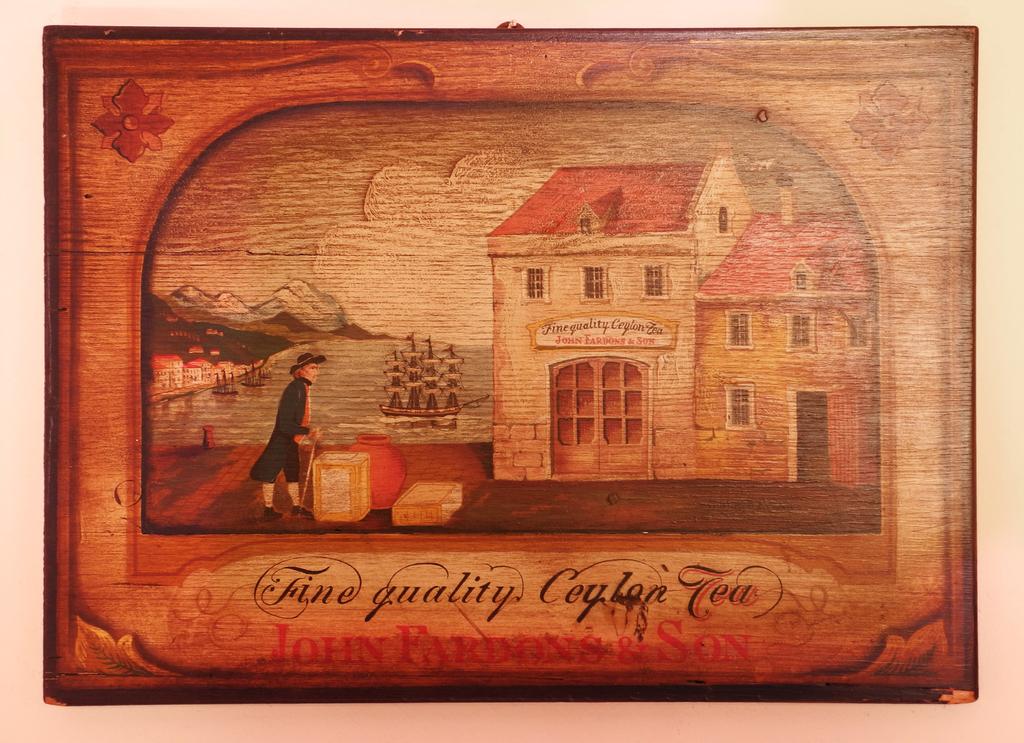What kind of quality is the tea?
Provide a succinct answer. Fine. What kind of tea?
Your answer should be very brief. Ceylon tea. 